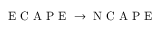Convert formula to latex. <formula><loc_0><loc_0><loc_500><loc_500>E C A P E \rightarrow N C A P E</formula> 